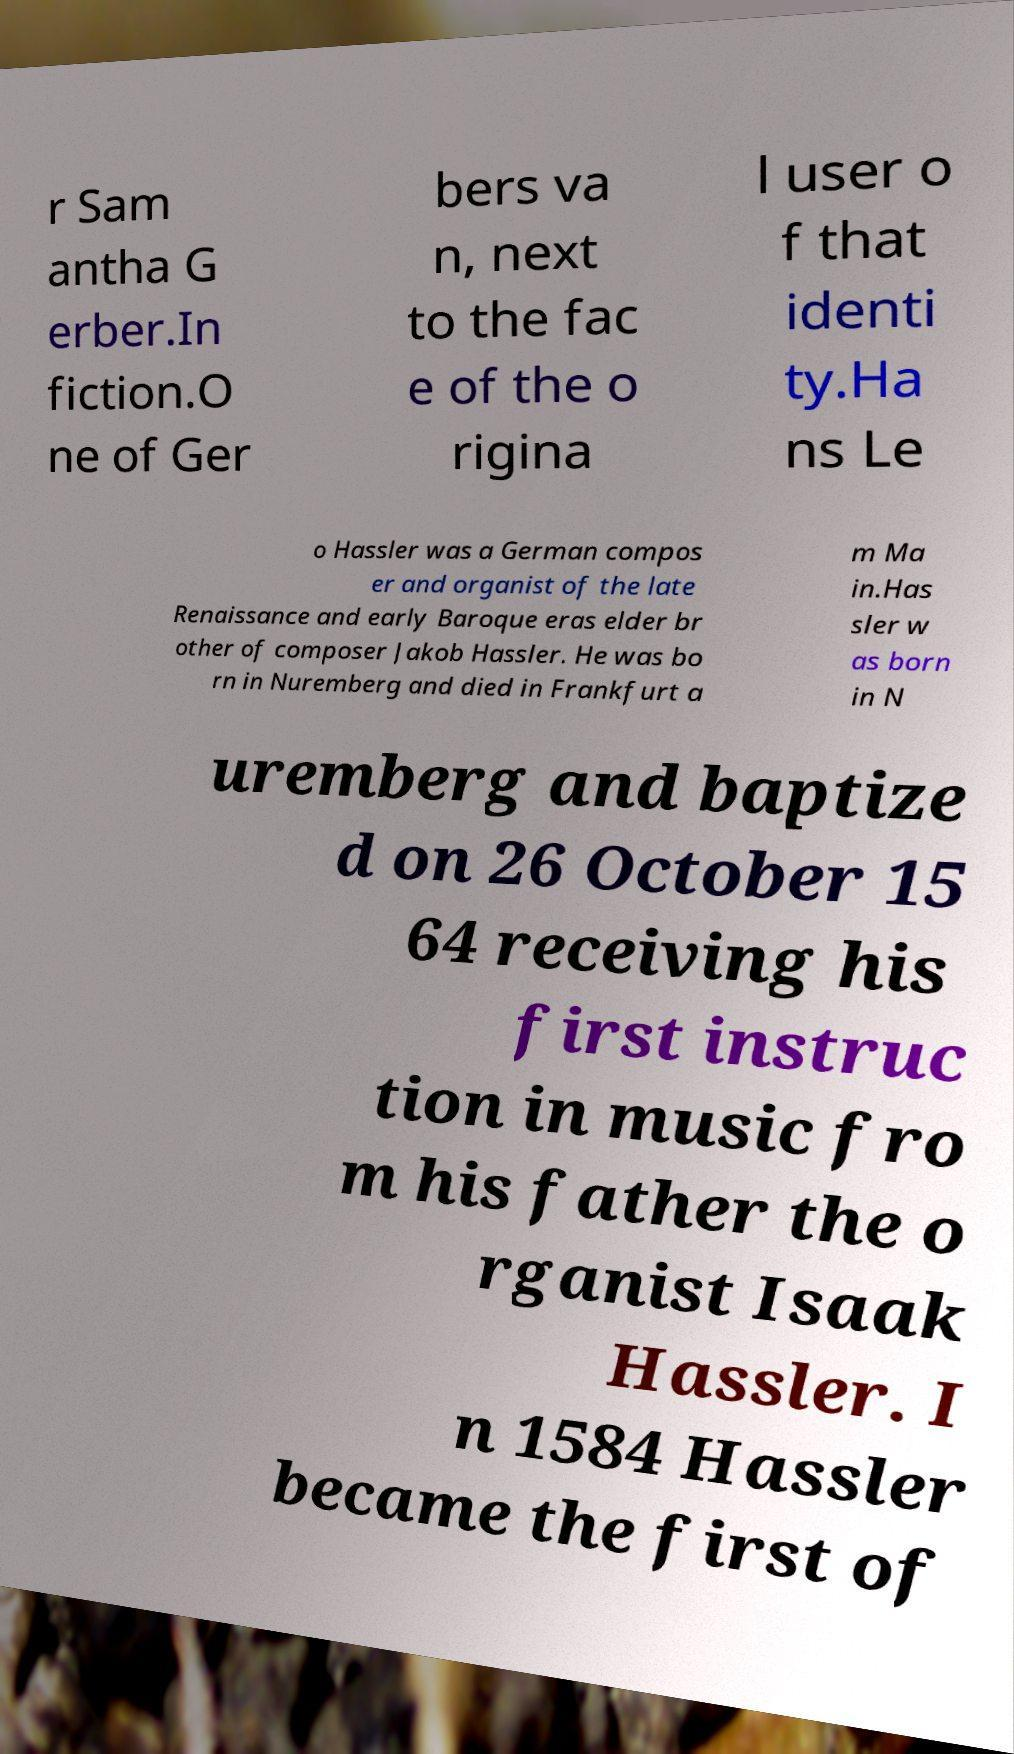Could you extract and type out the text from this image? r Sam antha G erber.In fiction.O ne of Ger bers va n, next to the fac e of the o rigina l user o f that identi ty.Ha ns Le o Hassler was a German compos er and organist of the late Renaissance and early Baroque eras elder br other of composer Jakob Hassler. He was bo rn in Nuremberg and died in Frankfurt a m Ma in.Has sler w as born in N uremberg and baptize d on 26 October 15 64 receiving his first instruc tion in music fro m his father the o rganist Isaak Hassler. I n 1584 Hassler became the first of 